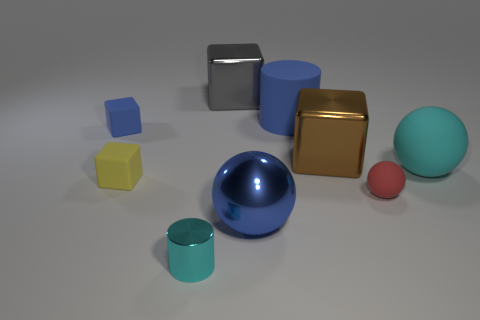How many large things are there?
Provide a succinct answer. 5. Does the small matte sphere have the same color as the large rubber cylinder?
Provide a succinct answer. No. Is the number of cyan balls that are on the left side of the big blue cylinder less than the number of big rubber cylinders left of the blue matte cube?
Offer a terse response. No. What is the color of the big cylinder?
Make the answer very short. Blue. What number of other large shiny spheres have the same color as the metallic ball?
Your response must be concise. 0. Are there any big gray shiny objects in front of the large brown object?
Make the answer very short. No. Is the number of large brown objects behind the big cyan object the same as the number of metallic cylinders to the left of the large blue metal sphere?
Your answer should be very brief. Yes. Is the size of the blue object that is left of the small cyan shiny thing the same as the shiny block to the right of the large gray metal thing?
Your answer should be compact. No. There is a tiny matte object on the right side of the cyan object on the left side of the large blue object in front of the tiny red rubber thing; what shape is it?
Give a very brief answer. Sphere. Are there any other things that have the same material as the blue sphere?
Make the answer very short. Yes. 